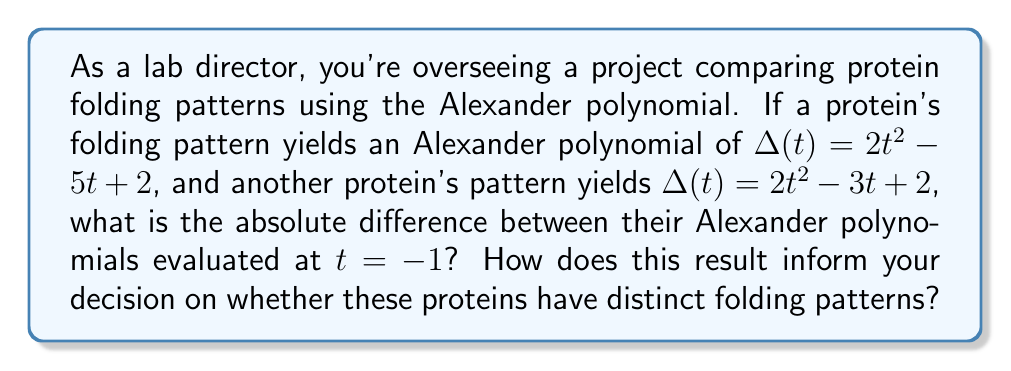Could you help me with this problem? 1. Recall that the Alexander polynomial evaluated at $t = -1$ is an important knot invariant.

2. For the first protein:
   $\Delta(-1) = 2(-1)^2 - 5(-1) + 2$
   $= 2(1) + 5 + 2 = 9$

3. For the second protein:
   $\Delta(-1) = 2(-1)^2 - 3(-1) + 2$
   $= 2(1) + 3 + 2 = 7$

4. The absolute difference is:
   $|9 - 7| = 2$

5. A non-zero difference in the Alexander polynomial evaluated at $t = -1$ suggests that these proteins likely have distinct folding patterns. However, as a cautious lab director, you should note that while this result strongly indicates different patterns, it's not definitive proof. Additional tests and analyses should be conducted to confirm this finding.
Answer: 2; Likely distinct folding patterns, but further confirmation needed. 